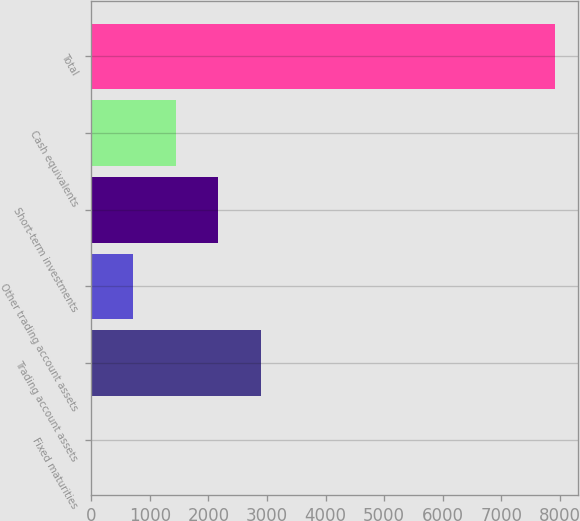<chart> <loc_0><loc_0><loc_500><loc_500><bar_chart><fcel>Fixed maturities<fcel>Trading account assets<fcel>Other trading account assets<fcel>Short-term investments<fcel>Cash equivalents<fcel>Total<nl><fcel>0.12<fcel>2894.08<fcel>723.61<fcel>2170.59<fcel>1447.1<fcel>7914.49<nl></chart> 